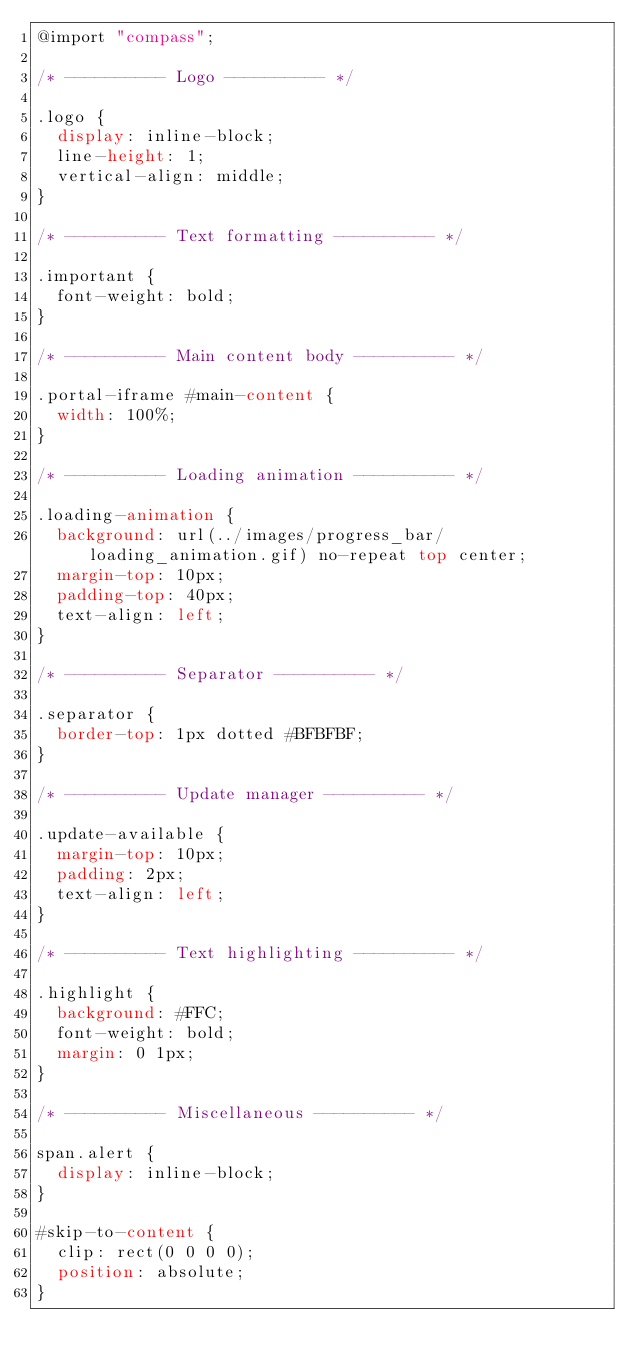Convert code to text. <code><loc_0><loc_0><loc_500><loc_500><_CSS_>@import "compass";

/* ---------- Logo ---------- */

.logo {
	display: inline-block;
	line-height: 1;
	vertical-align: middle;
}

/* ---------- Text formatting ---------- */

.important {
	font-weight: bold;
}

/* ---------- Main content body ---------- */

.portal-iframe #main-content {
	width: 100%;
}

/* ---------- Loading animation ---------- */

.loading-animation {
	background: url(../images/progress_bar/loading_animation.gif) no-repeat top center;
	margin-top: 10px;
	padding-top: 40px;
	text-align: left;
}

/* ---------- Separator ---------- */

.separator {
	border-top: 1px dotted #BFBFBF;
}

/* ---------- Update manager ---------- */

.update-available {
	margin-top: 10px;
	padding: 2px;
	text-align: left;
}

/* ---------- Text highlighting ---------- */

.highlight {
	background: #FFC;
	font-weight: bold;
	margin: 0 1px;
}

/* ---------- Miscellaneous ---------- */

span.alert {
	display: inline-block;
}

#skip-to-content {
	clip: rect(0 0 0 0);
	position: absolute;
}</code> 